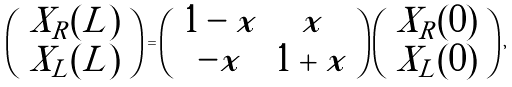Convert formula to latex. <formula><loc_0><loc_0><loc_500><loc_500>\left ( \begin{array} { c } X _ { R } ( L ) \\ X _ { L } ( L ) \end{array} \right ) = \left ( \begin{array} { c c } 1 - x & x \\ - x & 1 + x \end{array} \right ) \left ( \begin{array} { c } X _ { R } ( 0 ) \\ X _ { L } ( 0 ) \end{array} \right ) ,</formula> 